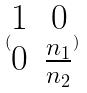<formula> <loc_0><loc_0><loc_500><loc_500>( \begin{matrix} 1 & 0 \\ 0 & \frac { n _ { 1 } } { n _ { 2 } } \end{matrix} )</formula> 